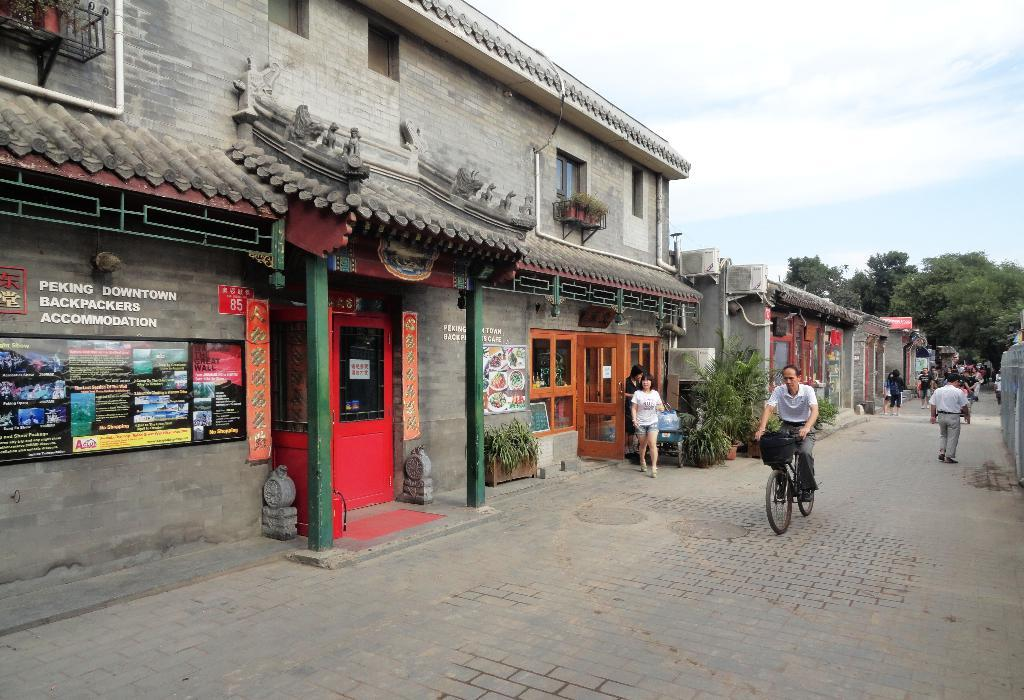What type of structures can be seen in the image? There are houses in the image. What type of vegetation is present in the image? There are plants, trees, and possibly bushes in the image. What mode of transportation is visible in the image? There is a bicycle in the image. Are there any living beings in the image? Yes, there are people in the image. What architectural features can be seen in the image? There are doors and pillars in the image. What is the weather like in the image? The sky is cloudy in the image, suggesting a partly cloudy or overcast day. What objects can be seen in the image? There are various objects, including the houses, plants, trees, bicycle, people, doors, pillars, and possibly signs or boards. Is there any text or writing visible in the image? Yes, something is written on boards in the image. Can you see the toes of the people in the image? There is no specific detail about the people's toes in the image, so it cannot be determined whether they are visible or not. 